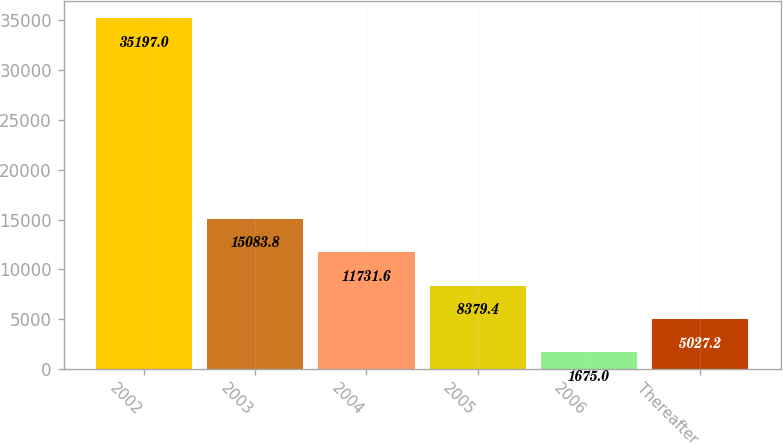Convert chart to OTSL. <chart><loc_0><loc_0><loc_500><loc_500><bar_chart><fcel>2002<fcel>2003<fcel>2004<fcel>2005<fcel>2006<fcel>Thereafter<nl><fcel>35197<fcel>15083.8<fcel>11731.6<fcel>8379.4<fcel>1675<fcel>5027.2<nl></chart> 